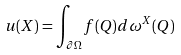Convert formula to latex. <formula><loc_0><loc_0><loc_500><loc_500>u ( X ) = \int _ { \partial \Omega } f ( Q ) d \omega ^ { X } ( Q )</formula> 